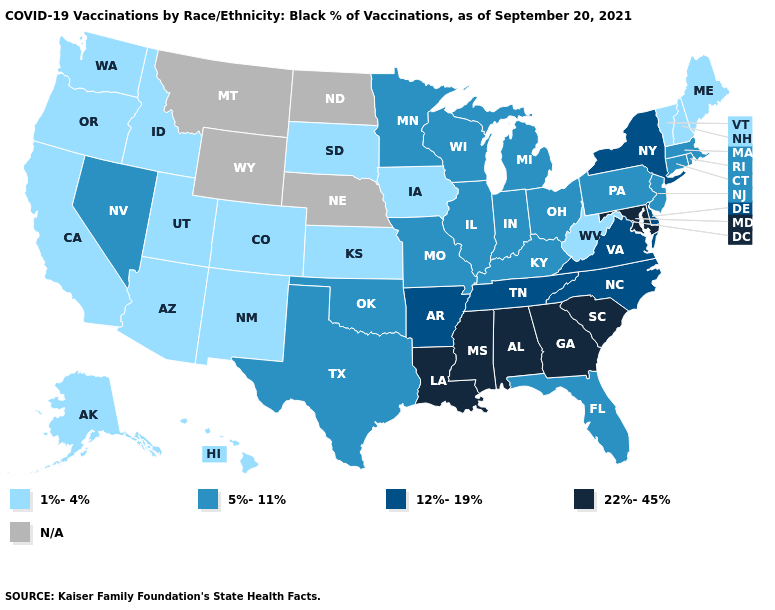What is the value of Pennsylvania?
Short answer required. 5%-11%. What is the highest value in the USA?
Short answer required. 22%-45%. Which states have the lowest value in the South?
Be succinct. West Virginia. Name the states that have a value in the range 22%-45%?
Be succinct. Alabama, Georgia, Louisiana, Maryland, Mississippi, South Carolina. Name the states that have a value in the range 22%-45%?
Quick response, please. Alabama, Georgia, Louisiana, Maryland, Mississippi, South Carolina. What is the value of New Mexico?
Write a very short answer. 1%-4%. Which states have the highest value in the USA?
Short answer required. Alabama, Georgia, Louisiana, Maryland, Mississippi, South Carolina. What is the highest value in the Northeast ?
Quick response, please. 12%-19%. What is the value of North Dakota?
Give a very brief answer. N/A. What is the value of Oregon?
Keep it brief. 1%-4%. Name the states that have a value in the range 22%-45%?
Quick response, please. Alabama, Georgia, Louisiana, Maryland, Mississippi, South Carolina. Which states have the lowest value in the USA?
Quick response, please. Alaska, Arizona, California, Colorado, Hawaii, Idaho, Iowa, Kansas, Maine, New Hampshire, New Mexico, Oregon, South Dakota, Utah, Vermont, Washington, West Virginia. 